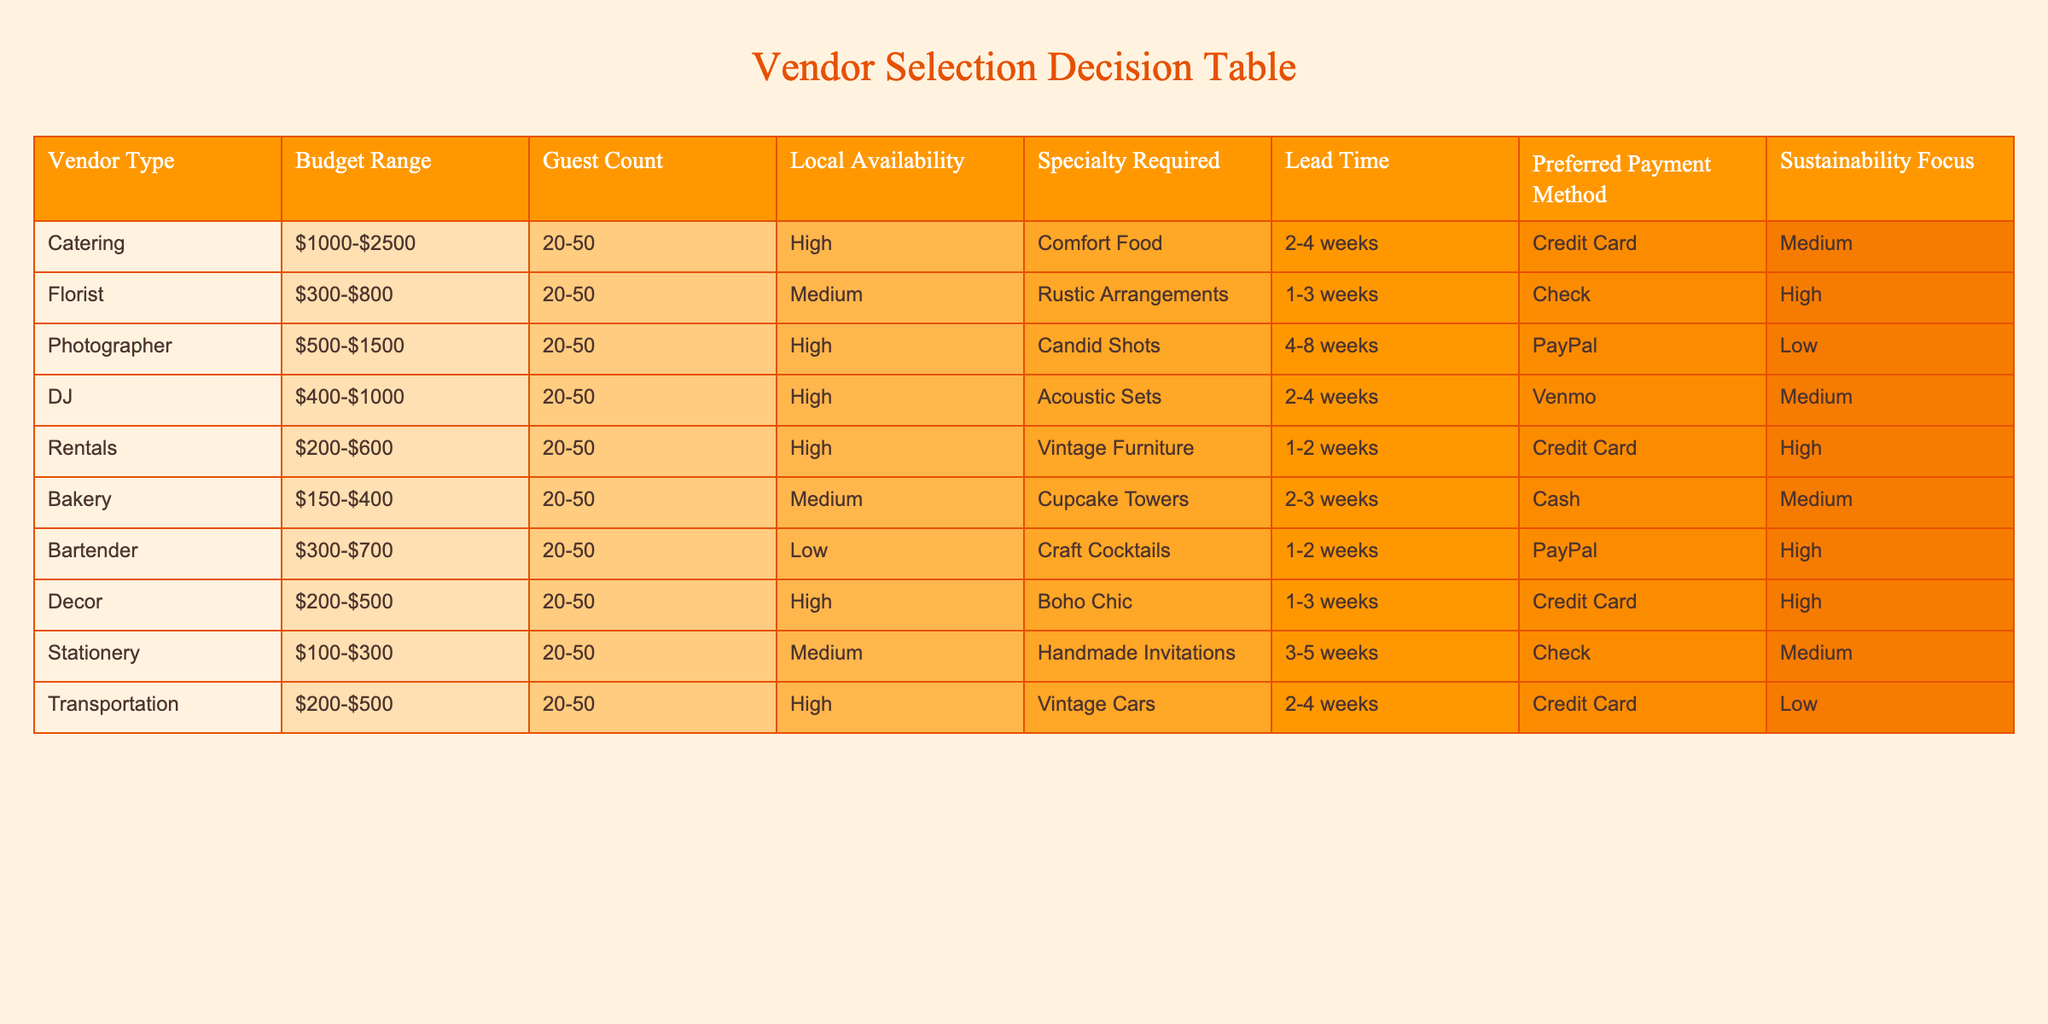What is the budget range for catering services? The budget range for catering services is listed in the table under the "Budget Range" column for the Catering row. It indicates that catering services range from $1000 to $2500.
Answer: $1000-$2500 How many vendor types have a high sustainability focus? To find the number of vendor types with a high sustainability focus, I check the "Sustainability Focus" column for entries marked as "High." The table shows Florist, Rentals, Decor, and Bartender as having high sustainability focus, totaling four vendor types.
Answer: 4 Is there a vendor type that specializes in vintage furniture? By reviewing the "Specialty Required" column, I see that the Rentals vendor type specializes in vintage furniture. This indicates that there is indeed a vendor type that focuses on vintage furniture.
Answer: Yes What is the lead time for the bakery service? The lead time for bakery services can be found in the corresponding row of the table under the "Lead Time" column. It states that the bakery service requires a lead time of 2-3 weeks.
Answer: 2-3 weeks Which vendor types have a medium preferred payment method? To determine vendor types with a medium preferred payment method, I check the "Preferred Payment Method" column for entries that list "Medium." The vendors that meet this criterion include Catering, DJ, Bakery, and Stationery, totaling four vendor types.
Answer: 4 What is the average budget range for the bartender and florist services combined? First, I convert the budget ranges for Bartender ($300-$700) and Florist ($300-$800) into numerical values. For Bartender, the average of 300 and 700 is 500, and for Florist, the average of 300 and 800 is 550. Then, I sum these two averages: 500 + 550 = 1050. Finally, the combined average of these two services is 1050 / 2 = 525.
Answer: 525 How many vendors have high local availability? To find this, I review the "Local Availability" column and count the number of entries marked as "High." The vendor types that have high local availability are Catering, Photographer, DJ, Rentals, Decor, and Transportation, totaling six vendors.
Answer: 6 Are there any vendors that require a lead time of less than 2 weeks? Checking the table, I find that all vendors listed have a lead time of at least 1 week, with the shortest being 1-2 weeks for Rentals and Bartender. Therefore, no vendors require less than 2 weeks.
Answer: No Which vendor has the highest budget range, and what is that range? Looking through the "Budget Range" for each vendor type, I identify that Catering has the highest budget range of $1000-$2500, making it the vendor with the highest range.
Answer: $1000-$2500 